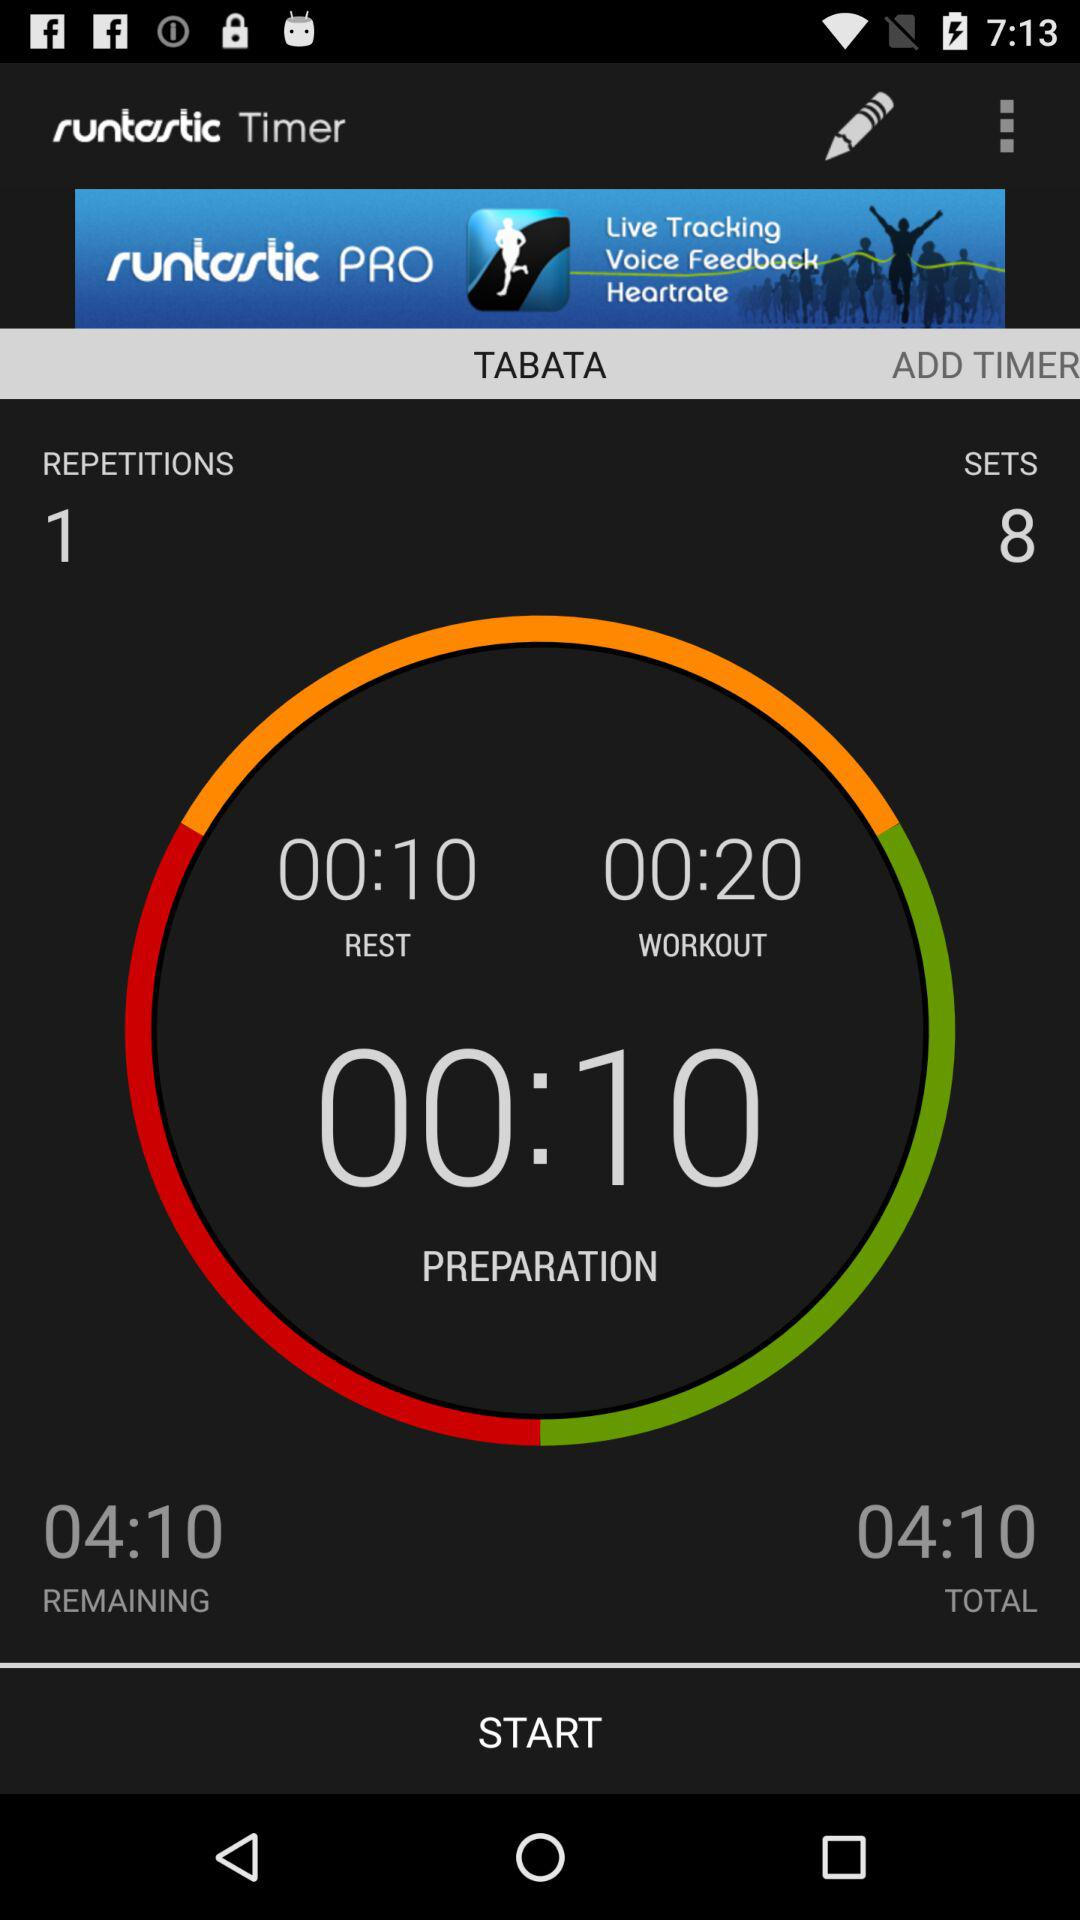What is the total time? The total time is 4 minutes 10 seconds. 